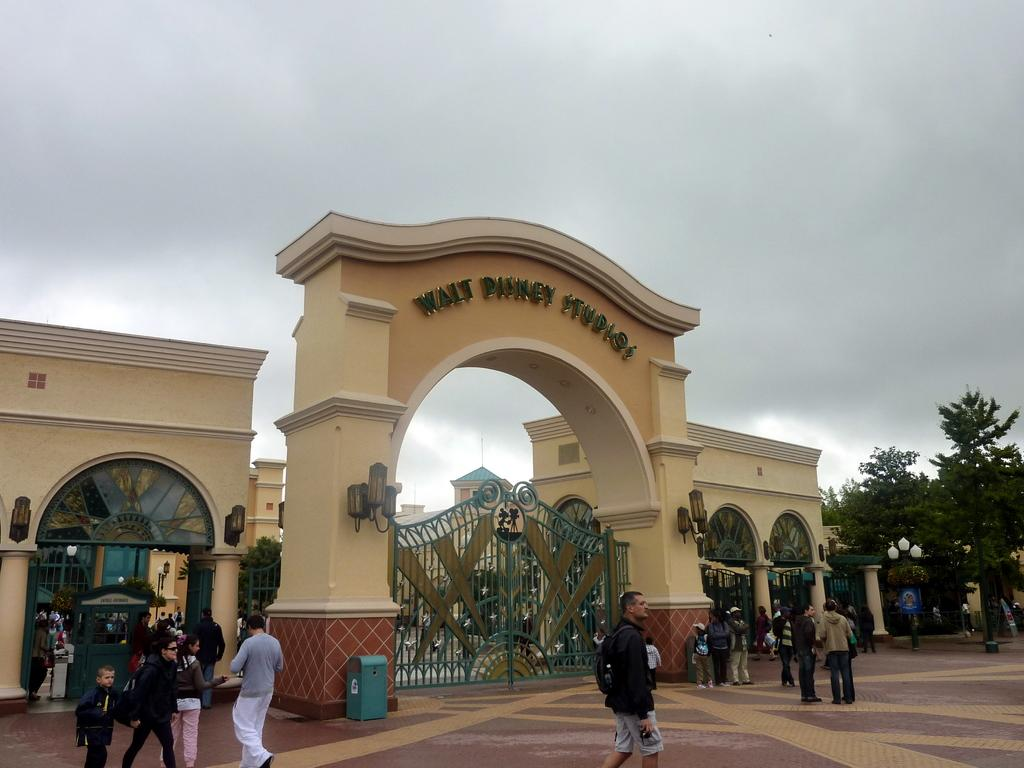<image>
Create a compact narrative representing the image presented. Tourists mill about the Walt Disney Studios arch. 